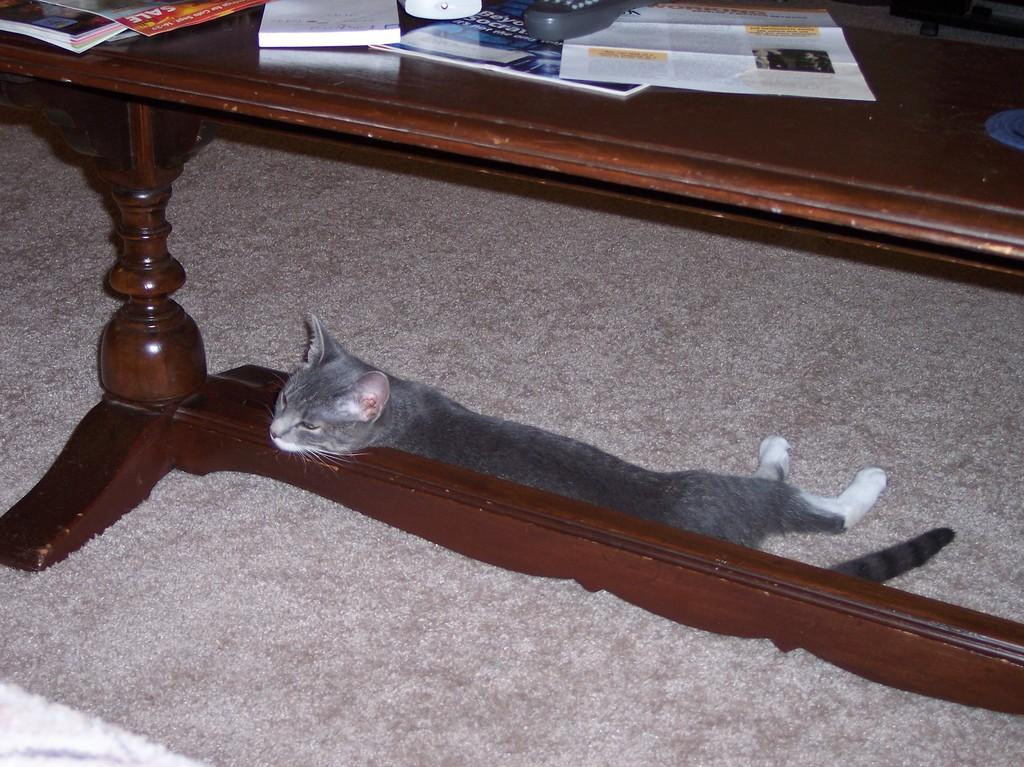What type of animal is in the image? There is a cat in the image. Where is the cat located in the image? The cat is under a table in the table. What items are on the table in the image? There are books, a remote, and a paper on the table. How much was the payment for the books in the image? There is no indication of payment or any financial transaction in the image. 